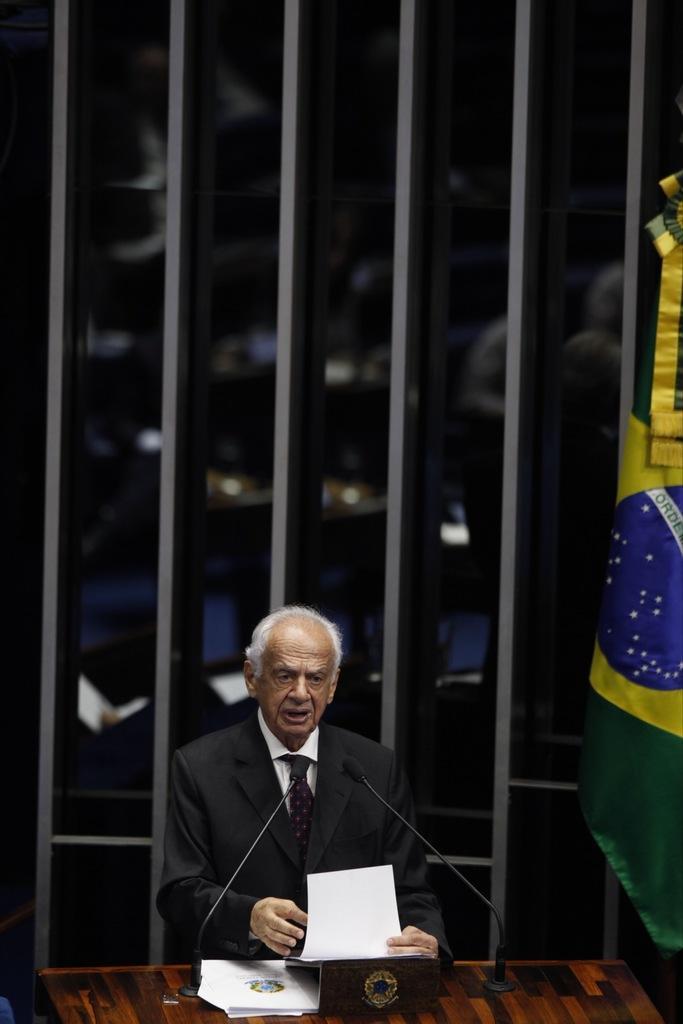Can you describe this image briefly? At the bottom of the picture, we see a man in white shirt and black blazer is standing. In front of him, we see a podium on which papers and microphones are placed. He is holding a paper in his hand. He is talking on the microphone. On the right side, we see a flag in green, blue and yellow color. Behind him, we see a long iron railing. In the background, it is blurred. 